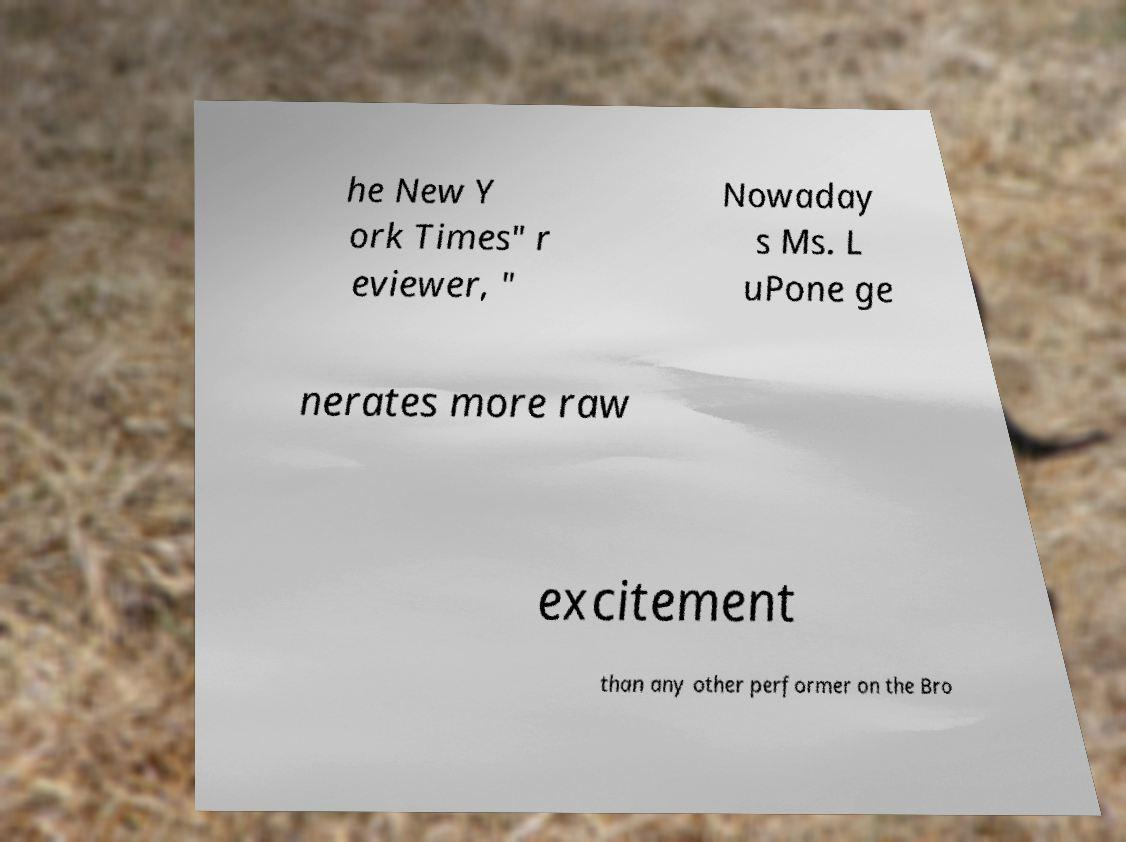Could you extract and type out the text from this image? he New Y ork Times" r eviewer, " Nowaday s Ms. L uPone ge nerates more raw excitement than any other performer on the Bro 